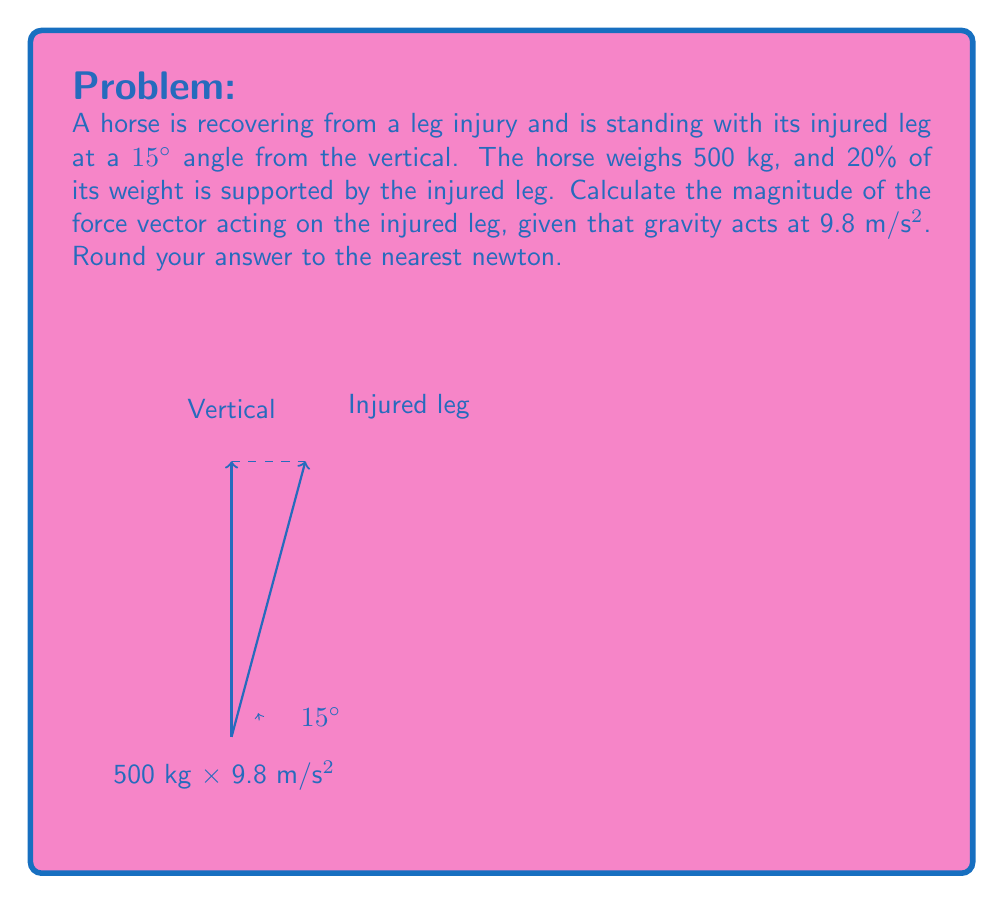Can you answer this question? Let's approach this step-by-step:

1) First, calculate the total weight of the horse:
   $$W = mg = 500 \text{ kg} \times 9.8 \text{ m/s}^2 = 4900 \text{ N}$$

2) The injured leg supports 20% of this weight:
   $$F_{\text{vertical}} = 20\% \times 4900 \text{ N} = 0.2 \times 4900 \text{ N} = 980 \text{ N}$$

3) This vertical force is a component of the total force acting along the leg. We need to find the magnitude of this total force.

4) The leg is at a 15° angle from vertical. Let's call the magnitude of the total force $F$. Then:
   $$\cos 15° = \frac{F_{\text{vertical}}}{F}$$

5) Rearranging this equation:
   $$F = \frac{F_{\text{vertical}}}{\cos 15°}$$

6) Substituting the known values:
   $$F = \frac{980 \text{ N}}{\cos 15°}$$

7) Calculate:
   $$F = \frac{980}{0.9659} \approx 1014.60 \text{ N}$$

8) Rounding to the nearest newton:
   $$F \approx 1015 \text{ N}$$
Answer: 1015 N 